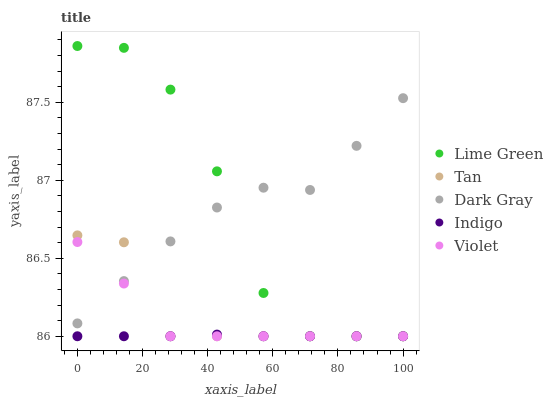Does Indigo have the minimum area under the curve?
Answer yes or no. Yes. Does Dark Gray have the maximum area under the curve?
Answer yes or no. Yes. Does Tan have the minimum area under the curve?
Answer yes or no. No. Does Tan have the maximum area under the curve?
Answer yes or no. No. Is Indigo the smoothest?
Answer yes or no. Yes. Is Lime Green the roughest?
Answer yes or no. Yes. Is Tan the smoothest?
Answer yes or no. No. Is Tan the roughest?
Answer yes or no. No. Does Indigo have the lowest value?
Answer yes or no. Yes. Does Lime Green have the highest value?
Answer yes or no. Yes. Does Tan have the highest value?
Answer yes or no. No. Is Indigo less than Dark Gray?
Answer yes or no. Yes. Is Dark Gray greater than Indigo?
Answer yes or no. Yes. Does Tan intersect Indigo?
Answer yes or no. Yes. Is Tan less than Indigo?
Answer yes or no. No. Is Tan greater than Indigo?
Answer yes or no. No. Does Indigo intersect Dark Gray?
Answer yes or no. No. 